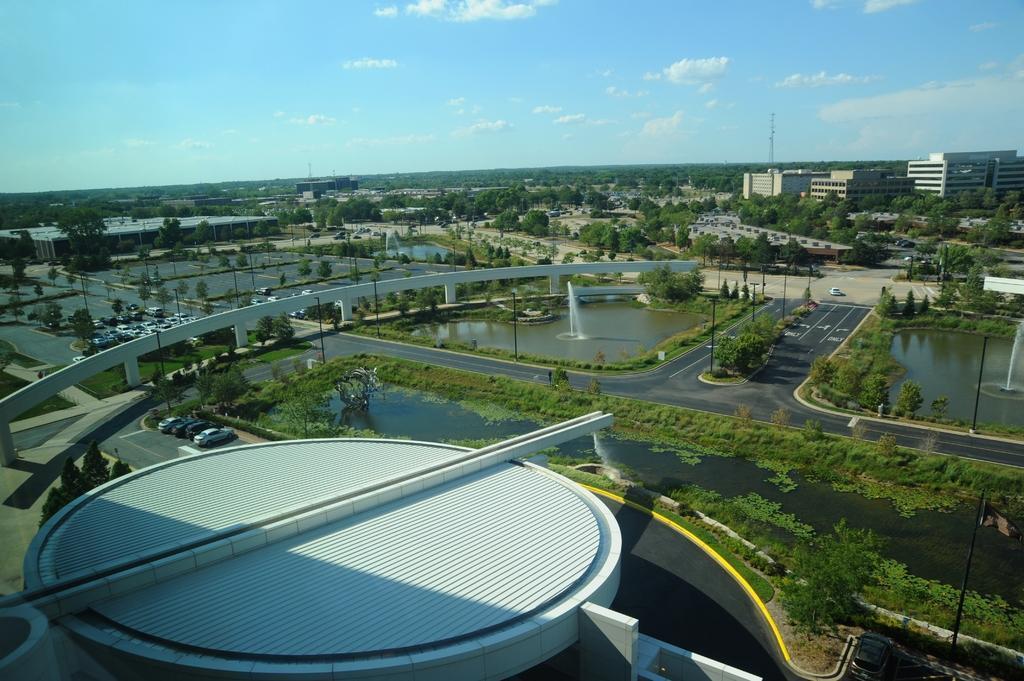How would you summarize this image in a sentence or two? In the center of the image there is a bridge. There is water. There is a road. There are plants. In the background of the image there are tree. There are buildings. There is a fountain. To the bottom of the image there is a concrete structure. 